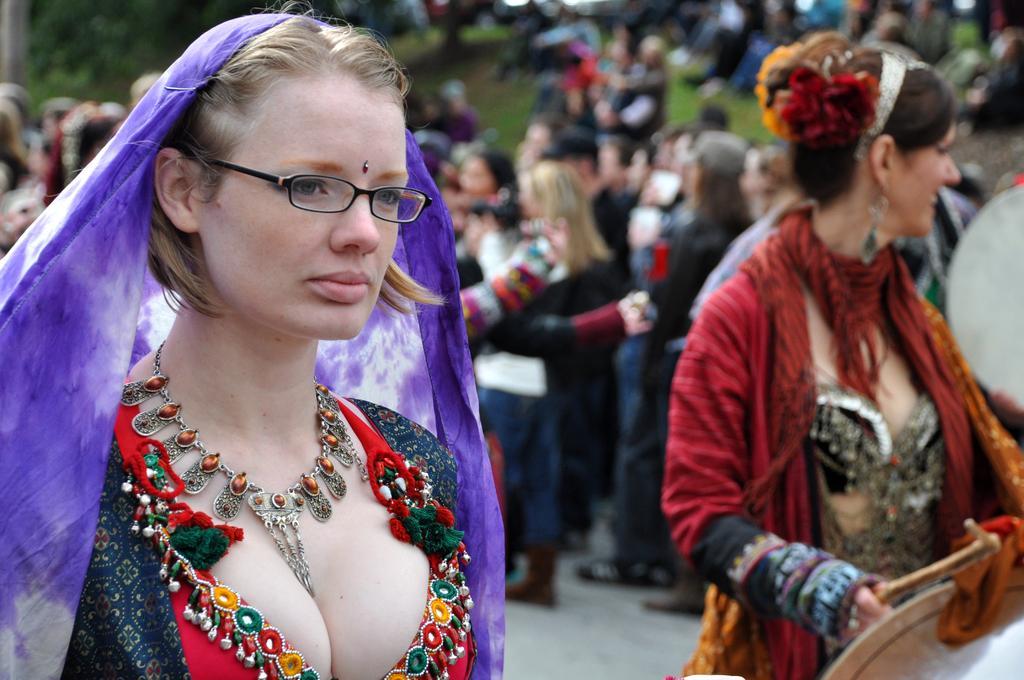Could you give a brief overview of what you see in this image? In this picture we can see there are two women in the fancy dress and behind the women there are groups of people, some are standing and some people are sitting on the path and there are some blurred items. 